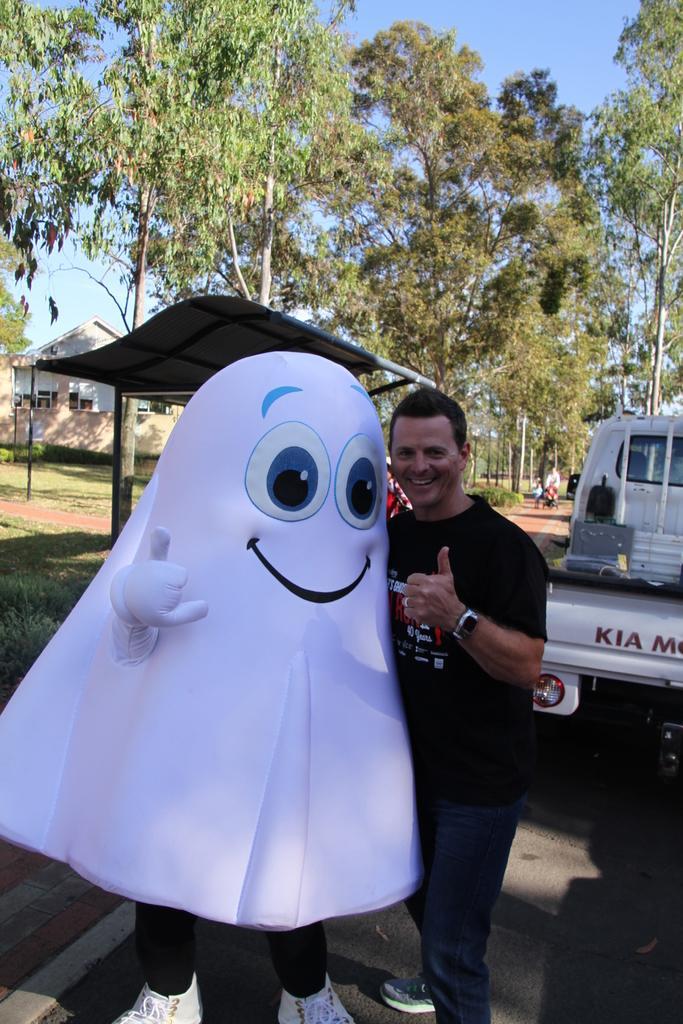How would you summarize this image in a sentence or two? In the center of the image we can see a man standing, next to him there is a clown. In the background there is a vehicle on the road, shed, building, trees and sky. 